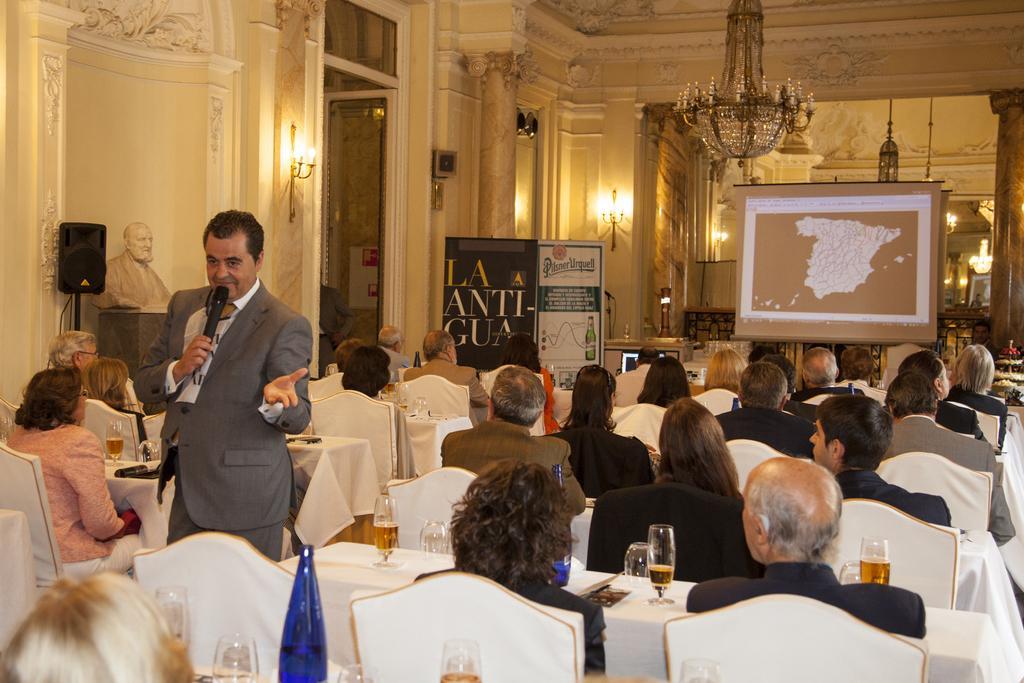Can you describe this image briefly? Here we can see a group of people are sitting on the chair, and a person is standing and holding a microphone in his hands, and in front here is the table and glasses on it, and here is the wall, and here is the lamp, and here is the pillar, and her is the chandelier. 